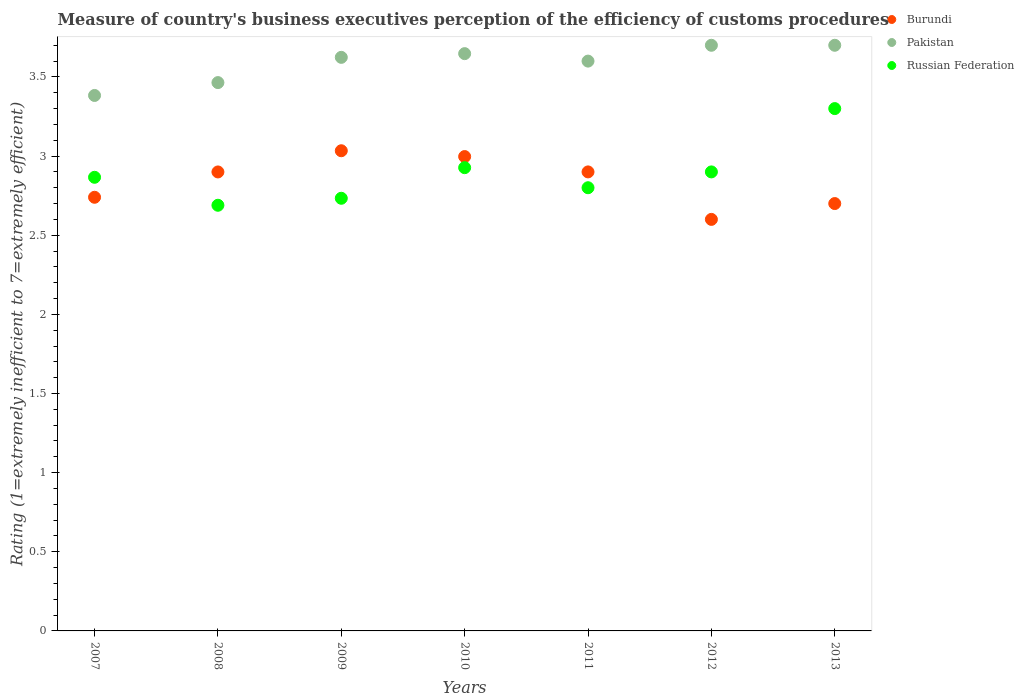How many different coloured dotlines are there?
Ensure brevity in your answer.  3. What is the rating of the efficiency of customs procedure in Russian Federation in 2011?
Give a very brief answer. 2.8. Across all years, what is the maximum rating of the efficiency of customs procedure in Russian Federation?
Your answer should be compact. 3.3. Across all years, what is the minimum rating of the efficiency of customs procedure in Russian Federation?
Provide a short and direct response. 2.69. What is the total rating of the efficiency of customs procedure in Russian Federation in the graph?
Your answer should be compact. 20.22. What is the difference between the rating of the efficiency of customs procedure in Burundi in 2012 and that in 2013?
Keep it short and to the point. -0.1. What is the difference between the rating of the efficiency of customs procedure in Burundi in 2013 and the rating of the efficiency of customs procedure in Russian Federation in 2007?
Ensure brevity in your answer.  -0.17. What is the average rating of the efficiency of customs procedure in Pakistan per year?
Your answer should be compact. 3.59. In the year 2007, what is the difference between the rating of the efficiency of customs procedure in Pakistan and rating of the efficiency of customs procedure in Burundi?
Your response must be concise. 0.64. What is the ratio of the rating of the efficiency of customs procedure in Russian Federation in 2012 to that in 2013?
Give a very brief answer. 0.88. Is the rating of the efficiency of customs procedure in Russian Federation in 2010 less than that in 2012?
Offer a very short reply. No. What is the difference between the highest and the second highest rating of the efficiency of customs procedure in Pakistan?
Provide a succinct answer. 0. What is the difference between the highest and the lowest rating of the efficiency of customs procedure in Russian Federation?
Provide a short and direct response. 0.61. Does the rating of the efficiency of customs procedure in Burundi monotonically increase over the years?
Provide a short and direct response. No. Is the rating of the efficiency of customs procedure in Pakistan strictly greater than the rating of the efficiency of customs procedure in Burundi over the years?
Make the answer very short. Yes. Does the graph contain any zero values?
Offer a terse response. No. Where does the legend appear in the graph?
Provide a succinct answer. Top right. How are the legend labels stacked?
Keep it short and to the point. Vertical. What is the title of the graph?
Offer a terse response. Measure of country's business executives perception of the efficiency of customs procedures. Does "Bhutan" appear as one of the legend labels in the graph?
Your answer should be compact. No. What is the label or title of the X-axis?
Provide a succinct answer. Years. What is the label or title of the Y-axis?
Your answer should be very brief. Rating (1=extremely inefficient to 7=extremely efficient). What is the Rating (1=extremely inefficient to 7=extremely efficient) of Burundi in 2007?
Your answer should be very brief. 2.74. What is the Rating (1=extremely inefficient to 7=extremely efficient) of Pakistan in 2007?
Offer a terse response. 3.38. What is the Rating (1=extremely inefficient to 7=extremely efficient) of Russian Federation in 2007?
Offer a very short reply. 2.87. What is the Rating (1=extremely inefficient to 7=extremely efficient) in Burundi in 2008?
Offer a terse response. 2.9. What is the Rating (1=extremely inefficient to 7=extremely efficient) of Pakistan in 2008?
Your answer should be very brief. 3.46. What is the Rating (1=extremely inefficient to 7=extremely efficient) in Russian Federation in 2008?
Keep it short and to the point. 2.69. What is the Rating (1=extremely inefficient to 7=extremely efficient) of Burundi in 2009?
Make the answer very short. 3.03. What is the Rating (1=extremely inefficient to 7=extremely efficient) in Pakistan in 2009?
Provide a short and direct response. 3.62. What is the Rating (1=extremely inefficient to 7=extremely efficient) in Russian Federation in 2009?
Ensure brevity in your answer.  2.73. What is the Rating (1=extremely inefficient to 7=extremely efficient) of Burundi in 2010?
Your answer should be very brief. 3. What is the Rating (1=extremely inefficient to 7=extremely efficient) of Pakistan in 2010?
Your answer should be very brief. 3.65. What is the Rating (1=extremely inefficient to 7=extremely efficient) of Russian Federation in 2010?
Your answer should be very brief. 2.93. What is the Rating (1=extremely inefficient to 7=extremely efficient) of Burundi in 2011?
Your answer should be compact. 2.9. What is the Rating (1=extremely inefficient to 7=extremely efficient) in Burundi in 2012?
Offer a terse response. 2.6. What is the Rating (1=extremely inefficient to 7=extremely efficient) in Pakistan in 2013?
Your answer should be compact. 3.7. Across all years, what is the maximum Rating (1=extremely inefficient to 7=extremely efficient) in Burundi?
Your answer should be compact. 3.03. Across all years, what is the maximum Rating (1=extremely inefficient to 7=extremely efficient) in Pakistan?
Make the answer very short. 3.7. Across all years, what is the minimum Rating (1=extremely inefficient to 7=extremely efficient) of Pakistan?
Give a very brief answer. 3.38. Across all years, what is the minimum Rating (1=extremely inefficient to 7=extremely efficient) in Russian Federation?
Provide a succinct answer. 2.69. What is the total Rating (1=extremely inefficient to 7=extremely efficient) of Burundi in the graph?
Give a very brief answer. 19.87. What is the total Rating (1=extremely inefficient to 7=extremely efficient) of Pakistan in the graph?
Keep it short and to the point. 25.12. What is the total Rating (1=extremely inefficient to 7=extremely efficient) in Russian Federation in the graph?
Your answer should be compact. 20.22. What is the difference between the Rating (1=extremely inefficient to 7=extremely efficient) in Burundi in 2007 and that in 2008?
Make the answer very short. -0.16. What is the difference between the Rating (1=extremely inefficient to 7=extremely efficient) of Pakistan in 2007 and that in 2008?
Provide a short and direct response. -0.08. What is the difference between the Rating (1=extremely inefficient to 7=extremely efficient) of Russian Federation in 2007 and that in 2008?
Ensure brevity in your answer.  0.18. What is the difference between the Rating (1=extremely inefficient to 7=extremely efficient) in Burundi in 2007 and that in 2009?
Keep it short and to the point. -0.29. What is the difference between the Rating (1=extremely inefficient to 7=extremely efficient) of Pakistan in 2007 and that in 2009?
Your response must be concise. -0.24. What is the difference between the Rating (1=extremely inefficient to 7=extremely efficient) of Russian Federation in 2007 and that in 2009?
Provide a short and direct response. 0.13. What is the difference between the Rating (1=extremely inefficient to 7=extremely efficient) in Burundi in 2007 and that in 2010?
Provide a short and direct response. -0.26. What is the difference between the Rating (1=extremely inefficient to 7=extremely efficient) of Pakistan in 2007 and that in 2010?
Make the answer very short. -0.26. What is the difference between the Rating (1=extremely inefficient to 7=extremely efficient) of Russian Federation in 2007 and that in 2010?
Make the answer very short. -0.06. What is the difference between the Rating (1=extremely inefficient to 7=extremely efficient) in Burundi in 2007 and that in 2011?
Your answer should be very brief. -0.16. What is the difference between the Rating (1=extremely inefficient to 7=extremely efficient) in Pakistan in 2007 and that in 2011?
Keep it short and to the point. -0.22. What is the difference between the Rating (1=extremely inefficient to 7=extremely efficient) of Russian Federation in 2007 and that in 2011?
Your answer should be very brief. 0.07. What is the difference between the Rating (1=extremely inefficient to 7=extremely efficient) in Burundi in 2007 and that in 2012?
Your response must be concise. 0.14. What is the difference between the Rating (1=extremely inefficient to 7=extremely efficient) in Pakistan in 2007 and that in 2012?
Your response must be concise. -0.32. What is the difference between the Rating (1=extremely inefficient to 7=extremely efficient) of Russian Federation in 2007 and that in 2012?
Offer a terse response. -0.03. What is the difference between the Rating (1=extremely inefficient to 7=extremely efficient) of Burundi in 2007 and that in 2013?
Your response must be concise. 0.04. What is the difference between the Rating (1=extremely inefficient to 7=extremely efficient) of Pakistan in 2007 and that in 2013?
Ensure brevity in your answer.  -0.32. What is the difference between the Rating (1=extremely inefficient to 7=extremely efficient) of Russian Federation in 2007 and that in 2013?
Your response must be concise. -0.43. What is the difference between the Rating (1=extremely inefficient to 7=extremely efficient) of Burundi in 2008 and that in 2009?
Your response must be concise. -0.13. What is the difference between the Rating (1=extremely inefficient to 7=extremely efficient) in Pakistan in 2008 and that in 2009?
Your response must be concise. -0.16. What is the difference between the Rating (1=extremely inefficient to 7=extremely efficient) in Russian Federation in 2008 and that in 2009?
Your answer should be compact. -0.04. What is the difference between the Rating (1=extremely inefficient to 7=extremely efficient) in Burundi in 2008 and that in 2010?
Keep it short and to the point. -0.1. What is the difference between the Rating (1=extremely inefficient to 7=extremely efficient) in Pakistan in 2008 and that in 2010?
Provide a succinct answer. -0.18. What is the difference between the Rating (1=extremely inefficient to 7=extremely efficient) of Russian Federation in 2008 and that in 2010?
Offer a terse response. -0.24. What is the difference between the Rating (1=extremely inefficient to 7=extremely efficient) in Burundi in 2008 and that in 2011?
Keep it short and to the point. -0. What is the difference between the Rating (1=extremely inefficient to 7=extremely efficient) of Pakistan in 2008 and that in 2011?
Ensure brevity in your answer.  -0.14. What is the difference between the Rating (1=extremely inefficient to 7=extremely efficient) in Russian Federation in 2008 and that in 2011?
Offer a terse response. -0.11. What is the difference between the Rating (1=extremely inefficient to 7=extremely efficient) of Burundi in 2008 and that in 2012?
Offer a terse response. 0.3. What is the difference between the Rating (1=extremely inefficient to 7=extremely efficient) in Pakistan in 2008 and that in 2012?
Provide a short and direct response. -0.24. What is the difference between the Rating (1=extremely inefficient to 7=extremely efficient) in Russian Federation in 2008 and that in 2012?
Keep it short and to the point. -0.21. What is the difference between the Rating (1=extremely inefficient to 7=extremely efficient) in Burundi in 2008 and that in 2013?
Your answer should be very brief. 0.2. What is the difference between the Rating (1=extremely inefficient to 7=extremely efficient) of Pakistan in 2008 and that in 2013?
Ensure brevity in your answer.  -0.24. What is the difference between the Rating (1=extremely inefficient to 7=extremely efficient) in Russian Federation in 2008 and that in 2013?
Your answer should be very brief. -0.61. What is the difference between the Rating (1=extremely inefficient to 7=extremely efficient) in Burundi in 2009 and that in 2010?
Offer a terse response. 0.04. What is the difference between the Rating (1=extremely inefficient to 7=extremely efficient) of Pakistan in 2009 and that in 2010?
Your answer should be compact. -0.02. What is the difference between the Rating (1=extremely inefficient to 7=extremely efficient) in Russian Federation in 2009 and that in 2010?
Offer a very short reply. -0.19. What is the difference between the Rating (1=extremely inefficient to 7=extremely efficient) in Burundi in 2009 and that in 2011?
Keep it short and to the point. 0.13. What is the difference between the Rating (1=extremely inefficient to 7=extremely efficient) of Pakistan in 2009 and that in 2011?
Give a very brief answer. 0.02. What is the difference between the Rating (1=extremely inefficient to 7=extremely efficient) in Russian Federation in 2009 and that in 2011?
Give a very brief answer. -0.07. What is the difference between the Rating (1=extremely inefficient to 7=extremely efficient) in Burundi in 2009 and that in 2012?
Give a very brief answer. 0.43. What is the difference between the Rating (1=extremely inefficient to 7=extremely efficient) in Pakistan in 2009 and that in 2012?
Provide a succinct answer. -0.08. What is the difference between the Rating (1=extremely inefficient to 7=extremely efficient) of Russian Federation in 2009 and that in 2012?
Your response must be concise. -0.17. What is the difference between the Rating (1=extremely inefficient to 7=extremely efficient) in Burundi in 2009 and that in 2013?
Make the answer very short. 0.33. What is the difference between the Rating (1=extremely inefficient to 7=extremely efficient) in Pakistan in 2009 and that in 2013?
Provide a short and direct response. -0.08. What is the difference between the Rating (1=extremely inefficient to 7=extremely efficient) of Russian Federation in 2009 and that in 2013?
Offer a very short reply. -0.57. What is the difference between the Rating (1=extremely inefficient to 7=extremely efficient) of Burundi in 2010 and that in 2011?
Provide a short and direct response. 0.1. What is the difference between the Rating (1=extremely inefficient to 7=extremely efficient) in Pakistan in 2010 and that in 2011?
Offer a terse response. 0.05. What is the difference between the Rating (1=extremely inefficient to 7=extremely efficient) in Russian Federation in 2010 and that in 2011?
Your response must be concise. 0.13. What is the difference between the Rating (1=extremely inefficient to 7=extremely efficient) in Burundi in 2010 and that in 2012?
Give a very brief answer. 0.4. What is the difference between the Rating (1=extremely inefficient to 7=extremely efficient) in Pakistan in 2010 and that in 2012?
Provide a succinct answer. -0.05. What is the difference between the Rating (1=extremely inefficient to 7=extremely efficient) of Russian Federation in 2010 and that in 2012?
Keep it short and to the point. 0.03. What is the difference between the Rating (1=extremely inefficient to 7=extremely efficient) in Burundi in 2010 and that in 2013?
Your answer should be compact. 0.3. What is the difference between the Rating (1=extremely inefficient to 7=extremely efficient) of Pakistan in 2010 and that in 2013?
Ensure brevity in your answer.  -0.05. What is the difference between the Rating (1=extremely inefficient to 7=extremely efficient) of Russian Federation in 2010 and that in 2013?
Provide a short and direct response. -0.37. What is the difference between the Rating (1=extremely inefficient to 7=extremely efficient) of Pakistan in 2011 and that in 2012?
Give a very brief answer. -0.1. What is the difference between the Rating (1=extremely inefficient to 7=extremely efficient) of Russian Federation in 2011 and that in 2012?
Make the answer very short. -0.1. What is the difference between the Rating (1=extremely inefficient to 7=extremely efficient) of Burundi in 2012 and that in 2013?
Your answer should be very brief. -0.1. What is the difference between the Rating (1=extremely inefficient to 7=extremely efficient) of Burundi in 2007 and the Rating (1=extremely inefficient to 7=extremely efficient) of Pakistan in 2008?
Provide a succinct answer. -0.72. What is the difference between the Rating (1=extremely inefficient to 7=extremely efficient) in Burundi in 2007 and the Rating (1=extremely inefficient to 7=extremely efficient) in Russian Federation in 2008?
Provide a succinct answer. 0.05. What is the difference between the Rating (1=extremely inefficient to 7=extremely efficient) of Pakistan in 2007 and the Rating (1=extremely inefficient to 7=extremely efficient) of Russian Federation in 2008?
Keep it short and to the point. 0.69. What is the difference between the Rating (1=extremely inefficient to 7=extremely efficient) in Burundi in 2007 and the Rating (1=extremely inefficient to 7=extremely efficient) in Pakistan in 2009?
Offer a terse response. -0.88. What is the difference between the Rating (1=extremely inefficient to 7=extremely efficient) of Burundi in 2007 and the Rating (1=extremely inefficient to 7=extremely efficient) of Russian Federation in 2009?
Ensure brevity in your answer.  0.01. What is the difference between the Rating (1=extremely inefficient to 7=extremely efficient) of Pakistan in 2007 and the Rating (1=extremely inefficient to 7=extremely efficient) of Russian Federation in 2009?
Your answer should be compact. 0.65. What is the difference between the Rating (1=extremely inefficient to 7=extremely efficient) in Burundi in 2007 and the Rating (1=extremely inefficient to 7=extremely efficient) in Pakistan in 2010?
Offer a terse response. -0.91. What is the difference between the Rating (1=extremely inefficient to 7=extremely efficient) in Burundi in 2007 and the Rating (1=extremely inefficient to 7=extremely efficient) in Russian Federation in 2010?
Ensure brevity in your answer.  -0.19. What is the difference between the Rating (1=extremely inefficient to 7=extremely efficient) of Pakistan in 2007 and the Rating (1=extremely inefficient to 7=extremely efficient) of Russian Federation in 2010?
Provide a succinct answer. 0.46. What is the difference between the Rating (1=extremely inefficient to 7=extremely efficient) in Burundi in 2007 and the Rating (1=extremely inefficient to 7=extremely efficient) in Pakistan in 2011?
Offer a very short reply. -0.86. What is the difference between the Rating (1=extremely inefficient to 7=extremely efficient) of Burundi in 2007 and the Rating (1=extremely inefficient to 7=extremely efficient) of Russian Federation in 2011?
Your response must be concise. -0.06. What is the difference between the Rating (1=extremely inefficient to 7=extremely efficient) in Pakistan in 2007 and the Rating (1=extremely inefficient to 7=extremely efficient) in Russian Federation in 2011?
Give a very brief answer. 0.58. What is the difference between the Rating (1=extremely inefficient to 7=extremely efficient) of Burundi in 2007 and the Rating (1=extremely inefficient to 7=extremely efficient) of Pakistan in 2012?
Offer a terse response. -0.96. What is the difference between the Rating (1=extremely inefficient to 7=extremely efficient) in Burundi in 2007 and the Rating (1=extremely inefficient to 7=extremely efficient) in Russian Federation in 2012?
Your answer should be very brief. -0.16. What is the difference between the Rating (1=extremely inefficient to 7=extremely efficient) in Pakistan in 2007 and the Rating (1=extremely inefficient to 7=extremely efficient) in Russian Federation in 2012?
Ensure brevity in your answer.  0.48. What is the difference between the Rating (1=extremely inefficient to 7=extremely efficient) of Burundi in 2007 and the Rating (1=extremely inefficient to 7=extremely efficient) of Pakistan in 2013?
Provide a succinct answer. -0.96. What is the difference between the Rating (1=extremely inefficient to 7=extremely efficient) in Burundi in 2007 and the Rating (1=extremely inefficient to 7=extremely efficient) in Russian Federation in 2013?
Provide a short and direct response. -0.56. What is the difference between the Rating (1=extremely inefficient to 7=extremely efficient) in Pakistan in 2007 and the Rating (1=extremely inefficient to 7=extremely efficient) in Russian Federation in 2013?
Offer a terse response. 0.08. What is the difference between the Rating (1=extremely inefficient to 7=extremely efficient) in Burundi in 2008 and the Rating (1=extremely inefficient to 7=extremely efficient) in Pakistan in 2009?
Keep it short and to the point. -0.72. What is the difference between the Rating (1=extremely inefficient to 7=extremely efficient) of Burundi in 2008 and the Rating (1=extremely inefficient to 7=extremely efficient) of Russian Federation in 2009?
Give a very brief answer. 0.17. What is the difference between the Rating (1=extremely inefficient to 7=extremely efficient) of Pakistan in 2008 and the Rating (1=extremely inefficient to 7=extremely efficient) of Russian Federation in 2009?
Offer a terse response. 0.73. What is the difference between the Rating (1=extremely inefficient to 7=extremely efficient) in Burundi in 2008 and the Rating (1=extremely inefficient to 7=extremely efficient) in Pakistan in 2010?
Your answer should be compact. -0.75. What is the difference between the Rating (1=extremely inefficient to 7=extremely efficient) in Burundi in 2008 and the Rating (1=extremely inefficient to 7=extremely efficient) in Russian Federation in 2010?
Your response must be concise. -0.03. What is the difference between the Rating (1=extremely inefficient to 7=extremely efficient) in Pakistan in 2008 and the Rating (1=extremely inefficient to 7=extremely efficient) in Russian Federation in 2010?
Your answer should be very brief. 0.54. What is the difference between the Rating (1=extremely inefficient to 7=extremely efficient) in Burundi in 2008 and the Rating (1=extremely inefficient to 7=extremely efficient) in Pakistan in 2011?
Give a very brief answer. -0.7. What is the difference between the Rating (1=extremely inefficient to 7=extremely efficient) of Burundi in 2008 and the Rating (1=extremely inefficient to 7=extremely efficient) of Russian Federation in 2011?
Your answer should be compact. 0.1. What is the difference between the Rating (1=extremely inefficient to 7=extremely efficient) of Pakistan in 2008 and the Rating (1=extremely inefficient to 7=extremely efficient) of Russian Federation in 2011?
Make the answer very short. 0.66. What is the difference between the Rating (1=extremely inefficient to 7=extremely efficient) in Burundi in 2008 and the Rating (1=extremely inefficient to 7=extremely efficient) in Pakistan in 2012?
Your answer should be very brief. -0.8. What is the difference between the Rating (1=extremely inefficient to 7=extremely efficient) of Burundi in 2008 and the Rating (1=extremely inefficient to 7=extremely efficient) of Russian Federation in 2012?
Your response must be concise. -0. What is the difference between the Rating (1=extremely inefficient to 7=extremely efficient) in Pakistan in 2008 and the Rating (1=extremely inefficient to 7=extremely efficient) in Russian Federation in 2012?
Provide a short and direct response. 0.56. What is the difference between the Rating (1=extremely inefficient to 7=extremely efficient) in Burundi in 2008 and the Rating (1=extremely inefficient to 7=extremely efficient) in Pakistan in 2013?
Give a very brief answer. -0.8. What is the difference between the Rating (1=extremely inefficient to 7=extremely efficient) in Burundi in 2008 and the Rating (1=extremely inefficient to 7=extremely efficient) in Russian Federation in 2013?
Provide a succinct answer. -0.4. What is the difference between the Rating (1=extremely inefficient to 7=extremely efficient) of Pakistan in 2008 and the Rating (1=extremely inefficient to 7=extremely efficient) of Russian Federation in 2013?
Ensure brevity in your answer.  0.16. What is the difference between the Rating (1=extremely inefficient to 7=extremely efficient) of Burundi in 2009 and the Rating (1=extremely inefficient to 7=extremely efficient) of Pakistan in 2010?
Your response must be concise. -0.61. What is the difference between the Rating (1=extremely inefficient to 7=extremely efficient) in Burundi in 2009 and the Rating (1=extremely inefficient to 7=extremely efficient) in Russian Federation in 2010?
Keep it short and to the point. 0.11. What is the difference between the Rating (1=extremely inefficient to 7=extremely efficient) of Pakistan in 2009 and the Rating (1=extremely inefficient to 7=extremely efficient) of Russian Federation in 2010?
Ensure brevity in your answer.  0.7. What is the difference between the Rating (1=extremely inefficient to 7=extremely efficient) in Burundi in 2009 and the Rating (1=extremely inefficient to 7=extremely efficient) in Pakistan in 2011?
Offer a terse response. -0.57. What is the difference between the Rating (1=extremely inefficient to 7=extremely efficient) in Burundi in 2009 and the Rating (1=extremely inefficient to 7=extremely efficient) in Russian Federation in 2011?
Make the answer very short. 0.23. What is the difference between the Rating (1=extremely inefficient to 7=extremely efficient) in Pakistan in 2009 and the Rating (1=extremely inefficient to 7=extremely efficient) in Russian Federation in 2011?
Your answer should be very brief. 0.82. What is the difference between the Rating (1=extremely inefficient to 7=extremely efficient) of Burundi in 2009 and the Rating (1=extremely inefficient to 7=extremely efficient) of Pakistan in 2012?
Offer a terse response. -0.67. What is the difference between the Rating (1=extremely inefficient to 7=extremely efficient) of Burundi in 2009 and the Rating (1=extremely inefficient to 7=extremely efficient) of Russian Federation in 2012?
Offer a terse response. 0.13. What is the difference between the Rating (1=extremely inefficient to 7=extremely efficient) in Pakistan in 2009 and the Rating (1=extremely inefficient to 7=extremely efficient) in Russian Federation in 2012?
Offer a very short reply. 0.72. What is the difference between the Rating (1=extremely inefficient to 7=extremely efficient) of Burundi in 2009 and the Rating (1=extremely inefficient to 7=extremely efficient) of Pakistan in 2013?
Ensure brevity in your answer.  -0.67. What is the difference between the Rating (1=extremely inefficient to 7=extremely efficient) of Burundi in 2009 and the Rating (1=extremely inefficient to 7=extremely efficient) of Russian Federation in 2013?
Your answer should be compact. -0.27. What is the difference between the Rating (1=extremely inefficient to 7=extremely efficient) in Pakistan in 2009 and the Rating (1=extremely inefficient to 7=extremely efficient) in Russian Federation in 2013?
Offer a very short reply. 0.32. What is the difference between the Rating (1=extremely inefficient to 7=extremely efficient) in Burundi in 2010 and the Rating (1=extremely inefficient to 7=extremely efficient) in Pakistan in 2011?
Your answer should be very brief. -0.6. What is the difference between the Rating (1=extremely inefficient to 7=extremely efficient) of Burundi in 2010 and the Rating (1=extremely inefficient to 7=extremely efficient) of Russian Federation in 2011?
Offer a very short reply. 0.2. What is the difference between the Rating (1=extremely inefficient to 7=extremely efficient) of Pakistan in 2010 and the Rating (1=extremely inefficient to 7=extremely efficient) of Russian Federation in 2011?
Make the answer very short. 0.85. What is the difference between the Rating (1=extremely inefficient to 7=extremely efficient) in Burundi in 2010 and the Rating (1=extremely inefficient to 7=extremely efficient) in Pakistan in 2012?
Ensure brevity in your answer.  -0.7. What is the difference between the Rating (1=extremely inefficient to 7=extremely efficient) in Burundi in 2010 and the Rating (1=extremely inefficient to 7=extremely efficient) in Russian Federation in 2012?
Keep it short and to the point. 0.1. What is the difference between the Rating (1=extremely inefficient to 7=extremely efficient) of Pakistan in 2010 and the Rating (1=extremely inefficient to 7=extremely efficient) of Russian Federation in 2012?
Your answer should be compact. 0.75. What is the difference between the Rating (1=extremely inefficient to 7=extremely efficient) of Burundi in 2010 and the Rating (1=extremely inefficient to 7=extremely efficient) of Pakistan in 2013?
Your response must be concise. -0.7. What is the difference between the Rating (1=extremely inefficient to 7=extremely efficient) in Burundi in 2010 and the Rating (1=extremely inefficient to 7=extremely efficient) in Russian Federation in 2013?
Offer a terse response. -0.3. What is the difference between the Rating (1=extremely inefficient to 7=extremely efficient) in Pakistan in 2010 and the Rating (1=extremely inefficient to 7=extremely efficient) in Russian Federation in 2013?
Make the answer very short. 0.35. What is the difference between the Rating (1=extremely inefficient to 7=extremely efficient) in Burundi in 2011 and the Rating (1=extremely inefficient to 7=extremely efficient) in Pakistan in 2012?
Provide a succinct answer. -0.8. What is the difference between the Rating (1=extremely inefficient to 7=extremely efficient) of Burundi in 2011 and the Rating (1=extremely inefficient to 7=extremely efficient) of Pakistan in 2013?
Offer a very short reply. -0.8. What is the difference between the Rating (1=extremely inefficient to 7=extremely efficient) in Burundi in 2011 and the Rating (1=extremely inefficient to 7=extremely efficient) in Russian Federation in 2013?
Give a very brief answer. -0.4. What is the difference between the Rating (1=extremely inefficient to 7=extremely efficient) of Pakistan in 2011 and the Rating (1=extremely inefficient to 7=extremely efficient) of Russian Federation in 2013?
Make the answer very short. 0.3. What is the difference between the Rating (1=extremely inefficient to 7=extremely efficient) in Burundi in 2012 and the Rating (1=extremely inefficient to 7=extremely efficient) in Pakistan in 2013?
Your response must be concise. -1.1. What is the average Rating (1=extremely inefficient to 7=extremely efficient) in Burundi per year?
Offer a very short reply. 2.84. What is the average Rating (1=extremely inefficient to 7=extremely efficient) in Pakistan per year?
Make the answer very short. 3.59. What is the average Rating (1=extremely inefficient to 7=extremely efficient) in Russian Federation per year?
Your response must be concise. 2.89. In the year 2007, what is the difference between the Rating (1=extremely inefficient to 7=extremely efficient) of Burundi and Rating (1=extremely inefficient to 7=extremely efficient) of Pakistan?
Ensure brevity in your answer.  -0.64. In the year 2007, what is the difference between the Rating (1=extremely inefficient to 7=extremely efficient) of Burundi and Rating (1=extremely inefficient to 7=extremely efficient) of Russian Federation?
Provide a succinct answer. -0.13. In the year 2007, what is the difference between the Rating (1=extremely inefficient to 7=extremely efficient) of Pakistan and Rating (1=extremely inefficient to 7=extremely efficient) of Russian Federation?
Provide a short and direct response. 0.52. In the year 2008, what is the difference between the Rating (1=extremely inefficient to 7=extremely efficient) of Burundi and Rating (1=extremely inefficient to 7=extremely efficient) of Pakistan?
Make the answer very short. -0.56. In the year 2008, what is the difference between the Rating (1=extremely inefficient to 7=extremely efficient) in Burundi and Rating (1=extremely inefficient to 7=extremely efficient) in Russian Federation?
Your answer should be compact. 0.21. In the year 2008, what is the difference between the Rating (1=extremely inefficient to 7=extremely efficient) of Pakistan and Rating (1=extremely inefficient to 7=extremely efficient) of Russian Federation?
Keep it short and to the point. 0.78. In the year 2009, what is the difference between the Rating (1=extremely inefficient to 7=extremely efficient) of Burundi and Rating (1=extremely inefficient to 7=extremely efficient) of Pakistan?
Your response must be concise. -0.59. In the year 2009, what is the difference between the Rating (1=extremely inefficient to 7=extremely efficient) in Burundi and Rating (1=extremely inefficient to 7=extremely efficient) in Russian Federation?
Your response must be concise. 0.3. In the year 2009, what is the difference between the Rating (1=extremely inefficient to 7=extremely efficient) in Pakistan and Rating (1=extremely inefficient to 7=extremely efficient) in Russian Federation?
Provide a succinct answer. 0.89. In the year 2010, what is the difference between the Rating (1=extremely inefficient to 7=extremely efficient) of Burundi and Rating (1=extremely inefficient to 7=extremely efficient) of Pakistan?
Offer a very short reply. -0.65. In the year 2010, what is the difference between the Rating (1=extremely inefficient to 7=extremely efficient) in Burundi and Rating (1=extremely inefficient to 7=extremely efficient) in Russian Federation?
Ensure brevity in your answer.  0.07. In the year 2010, what is the difference between the Rating (1=extremely inefficient to 7=extremely efficient) in Pakistan and Rating (1=extremely inefficient to 7=extremely efficient) in Russian Federation?
Ensure brevity in your answer.  0.72. In the year 2011, what is the difference between the Rating (1=extremely inefficient to 7=extremely efficient) of Burundi and Rating (1=extremely inefficient to 7=extremely efficient) of Pakistan?
Your answer should be very brief. -0.7. In the year 2011, what is the difference between the Rating (1=extremely inefficient to 7=extremely efficient) of Burundi and Rating (1=extremely inefficient to 7=extremely efficient) of Russian Federation?
Your answer should be very brief. 0.1. In the year 2012, what is the difference between the Rating (1=extremely inefficient to 7=extremely efficient) in Burundi and Rating (1=extremely inefficient to 7=extremely efficient) in Russian Federation?
Provide a succinct answer. -0.3. In the year 2012, what is the difference between the Rating (1=extremely inefficient to 7=extremely efficient) of Pakistan and Rating (1=extremely inefficient to 7=extremely efficient) of Russian Federation?
Offer a terse response. 0.8. In the year 2013, what is the difference between the Rating (1=extremely inefficient to 7=extremely efficient) in Pakistan and Rating (1=extremely inefficient to 7=extremely efficient) in Russian Federation?
Offer a very short reply. 0.4. What is the ratio of the Rating (1=extremely inefficient to 7=extremely efficient) of Burundi in 2007 to that in 2008?
Your answer should be compact. 0.94. What is the ratio of the Rating (1=extremely inefficient to 7=extremely efficient) in Pakistan in 2007 to that in 2008?
Make the answer very short. 0.98. What is the ratio of the Rating (1=extremely inefficient to 7=extremely efficient) in Russian Federation in 2007 to that in 2008?
Ensure brevity in your answer.  1.07. What is the ratio of the Rating (1=extremely inefficient to 7=extremely efficient) in Burundi in 2007 to that in 2009?
Provide a succinct answer. 0.9. What is the ratio of the Rating (1=extremely inefficient to 7=extremely efficient) of Pakistan in 2007 to that in 2009?
Provide a succinct answer. 0.93. What is the ratio of the Rating (1=extremely inefficient to 7=extremely efficient) in Russian Federation in 2007 to that in 2009?
Offer a very short reply. 1.05. What is the ratio of the Rating (1=extremely inefficient to 7=extremely efficient) of Burundi in 2007 to that in 2010?
Keep it short and to the point. 0.91. What is the ratio of the Rating (1=extremely inefficient to 7=extremely efficient) in Pakistan in 2007 to that in 2010?
Ensure brevity in your answer.  0.93. What is the ratio of the Rating (1=extremely inefficient to 7=extremely efficient) in Russian Federation in 2007 to that in 2010?
Ensure brevity in your answer.  0.98. What is the ratio of the Rating (1=extremely inefficient to 7=extremely efficient) in Burundi in 2007 to that in 2011?
Keep it short and to the point. 0.94. What is the ratio of the Rating (1=extremely inefficient to 7=extremely efficient) in Pakistan in 2007 to that in 2011?
Provide a succinct answer. 0.94. What is the ratio of the Rating (1=extremely inefficient to 7=extremely efficient) in Russian Federation in 2007 to that in 2011?
Your answer should be compact. 1.02. What is the ratio of the Rating (1=extremely inefficient to 7=extremely efficient) of Burundi in 2007 to that in 2012?
Offer a very short reply. 1.05. What is the ratio of the Rating (1=extremely inefficient to 7=extremely efficient) of Pakistan in 2007 to that in 2012?
Offer a terse response. 0.91. What is the ratio of the Rating (1=extremely inefficient to 7=extremely efficient) of Russian Federation in 2007 to that in 2012?
Your answer should be compact. 0.99. What is the ratio of the Rating (1=extremely inefficient to 7=extremely efficient) in Burundi in 2007 to that in 2013?
Offer a terse response. 1.01. What is the ratio of the Rating (1=extremely inefficient to 7=extremely efficient) in Pakistan in 2007 to that in 2013?
Your response must be concise. 0.91. What is the ratio of the Rating (1=extremely inefficient to 7=extremely efficient) of Russian Federation in 2007 to that in 2013?
Give a very brief answer. 0.87. What is the ratio of the Rating (1=extremely inefficient to 7=extremely efficient) in Burundi in 2008 to that in 2009?
Ensure brevity in your answer.  0.96. What is the ratio of the Rating (1=extremely inefficient to 7=extremely efficient) of Pakistan in 2008 to that in 2009?
Your answer should be compact. 0.96. What is the ratio of the Rating (1=extremely inefficient to 7=extremely efficient) in Russian Federation in 2008 to that in 2009?
Make the answer very short. 0.98. What is the ratio of the Rating (1=extremely inefficient to 7=extremely efficient) of Burundi in 2008 to that in 2010?
Your answer should be compact. 0.97. What is the ratio of the Rating (1=extremely inefficient to 7=extremely efficient) in Pakistan in 2008 to that in 2010?
Provide a short and direct response. 0.95. What is the ratio of the Rating (1=extremely inefficient to 7=extremely efficient) of Russian Federation in 2008 to that in 2010?
Your response must be concise. 0.92. What is the ratio of the Rating (1=extremely inefficient to 7=extremely efficient) of Pakistan in 2008 to that in 2011?
Your answer should be compact. 0.96. What is the ratio of the Rating (1=extremely inefficient to 7=extremely efficient) in Russian Federation in 2008 to that in 2011?
Ensure brevity in your answer.  0.96. What is the ratio of the Rating (1=extremely inefficient to 7=extremely efficient) of Burundi in 2008 to that in 2012?
Provide a short and direct response. 1.12. What is the ratio of the Rating (1=extremely inefficient to 7=extremely efficient) in Pakistan in 2008 to that in 2012?
Give a very brief answer. 0.94. What is the ratio of the Rating (1=extremely inefficient to 7=extremely efficient) in Russian Federation in 2008 to that in 2012?
Make the answer very short. 0.93. What is the ratio of the Rating (1=extremely inefficient to 7=extremely efficient) of Burundi in 2008 to that in 2013?
Provide a succinct answer. 1.07. What is the ratio of the Rating (1=extremely inefficient to 7=extremely efficient) of Pakistan in 2008 to that in 2013?
Ensure brevity in your answer.  0.94. What is the ratio of the Rating (1=extremely inefficient to 7=extremely efficient) of Russian Federation in 2008 to that in 2013?
Keep it short and to the point. 0.81. What is the ratio of the Rating (1=extremely inefficient to 7=extremely efficient) of Burundi in 2009 to that in 2010?
Provide a short and direct response. 1.01. What is the ratio of the Rating (1=extremely inefficient to 7=extremely efficient) in Russian Federation in 2009 to that in 2010?
Your response must be concise. 0.93. What is the ratio of the Rating (1=extremely inefficient to 7=extremely efficient) of Burundi in 2009 to that in 2011?
Offer a terse response. 1.05. What is the ratio of the Rating (1=extremely inefficient to 7=extremely efficient) of Pakistan in 2009 to that in 2011?
Make the answer very short. 1.01. What is the ratio of the Rating (1=extremely inefficient to 7=extremely efficient) in Russian Federation in 2009 to that in 2011?
Ensure brevity in your answer.  0.98. What is the ratio of the Rating (1=extremely inefficient to 7=extremely efficient) in Burundi in 2009 to that in 2012?
Offer a terse response. 1.17. What is the ratio of the Rating (1=extremely inefficient to 7=extremely efficient) in Pakistan in 2009 to that in 2012?
Ensure brevity in your answer.  0.98. What is the ratio of the Rating (1=extremely inefficient to 7=extremely efficient) of Russian Federation in 2009 to that in 2012?
Ensure brevity in your answer.  0.94. What is the ratio of the Rating (1=extremely inefficient to 7=extremely efficient) of Burundi in 2009 to that in 2013?
Your answer should be very brief. 1.12. What is the ratio of the Rating (1=extremely inefficient to 7=extremely efficient) in Pakistan in 2009 to that in 2013?
Keep it short and to the point. 0.98. What is the ratio of the Rating (1=extremely inefficient to 7=extremely efficient) in Russian Federation in 2009 to that in 2013?
Your answer should be very brief. 0.83. What is the ratio of the Rating (1=extremely inefficient to 7=extremely efficient) in Burundi in 2010 to that in 2011?
Ensure brevity in your answer.  1.03. What is the ratio of the Rating (1=extremely inefficient to 7=extremely efficient) of Pakistan in 2010 to that in 2011?
Give a very brief answer. 1.01. What is the ratio of the Rating (1=extremely inefficient to 7=extremely efficient) in Russian Federation in 2010 to that in 2011?
Keep it short and to the point. 1.05. What is the ratio of the Rating (1=extremely inefficient to 7=extremely efficient) in Burundi in 2010 to that in 2012?
Keep it short and to the point. 1.15. What is the ratio of the Rating (1=extremely inefficient to 7=extremely efficient) of Pakistan in 2010 to that in 2012?
Your answer should be compact. 0.99. What is the ratio of the Rating (1=extremely inefficient to 7=extremely efficient) of Russian Federation in 2010 to that in 2012?
Make the answer very short. 1.01. What is the ratio of the Rating (1=extremely inefficient to 7=extremely efficient) in Burundi in 2010 to that in 2013?
Your answer should be compact. 1.11. What is the ratio of the Rating (1=extremely inefficient to 7=extremely efficient) of Pakistan in 2010 to that in 2013?
Your response must be concise. 0.99. What is the ratio of the Rating (1=extremely inefficient to 7=extremely efficient) of Russian Federation in 2010 to that in 2013?
Your response must be concise. 0.89. What is the ratio of the Rating (1=extremely inefficient to 7=extremely efficient) in Burundi in 2011 to that in 2012?
Your response must be concise. 1.12. What is the ratio of the Rating (1=extremely inefficient to 7=extremely efficient) in Russian Federation in 2011 to that in 2012?
Ensure brevity in your answer.  0.97. What is the ratio of the Rating (1=extremely inefficient to 7=extremely efficient) of Burundi in 2011 to that in 2013?
Give a very brief answer. 1.07. What is the ratio of the Rating (1=extremely inefficient to 7=extremely efficient) in Russian Federation in 2011 to that in 2013?
Ensure brevity in your answer.  0.85. What is the ratio of the Rating (1=extremely inefficient to 7=extremely efficient) in Burundi in 2012 to that in 2013?
Your answer should be very brief. 0.96. What is the ratio of the Rating (1=extremely inefficient to 7=extremely efficient) of Russian Federation in 2012 to that in 2013?
Your answer should be compact. 0.88. What is the difference between the highest and the second highest Rating (1=extremely inefficient to 7=extremely efficient) of Burundi?
Your answer should be very brief. 0.04. What is the difference between the highest and the second highest Rating (1=extremely inefficient to 7=extremely efficient) of Pakistan?
Your answer should be compact. 0. What is the difference between the highest and the second highest Rating (1=extremely inefficient to 7=extremely efficient) in Russian Federation?
Offer a terse response. 0.37. What is the difference between the highest and the lowest Rating (1=extremely inefficient to 7=extremely efficient) in Burundi?
Your response must be concise. 0.43. What is the difference between the highest and the lowest Rating (1=extremely inefficient to 7=extremely efficient) of Pakistan?
Offer a terse response. 0.32. What is the difference between the highest and the lowest Rating (1=extremely inefficient to 7=extremely efficient) in Russian Federation?
Provide a succinct answer. 0.61. 